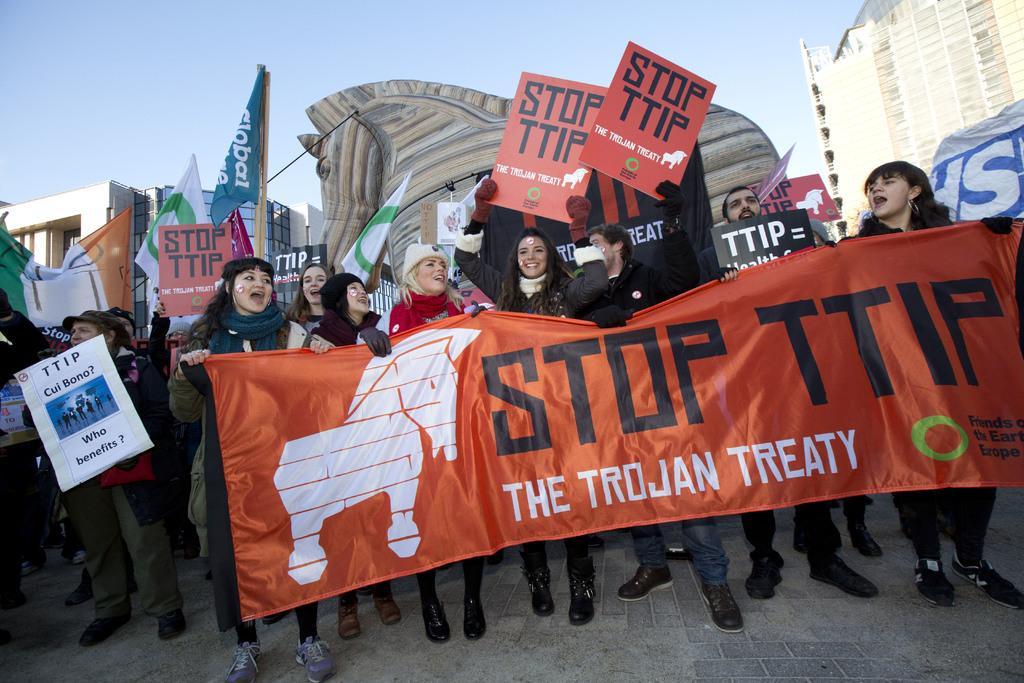Could you give a brief overview of what you see in this image? In this image I can see a crowd is standing on the road and are holding posters and boards in their hand. In the background I can see a horse statue, buildings and the sky. This image is taken may be on the road. 